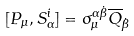<formula> <loc_0><loc_0><loc_500><loc_500>[ P _ { \mu } , S _ { \alpha } ^ { i } ] = \sigma _ { \mu } ^ { \alpha \dot { \beta } } \overline { Q } _ { \dot { \beta } }</formula> 